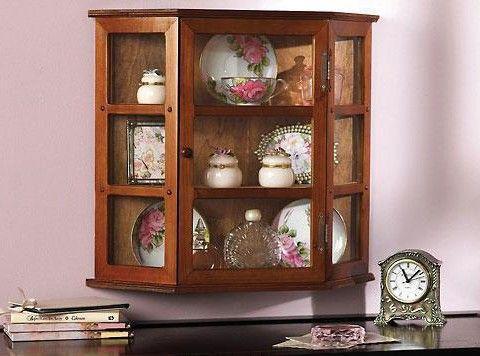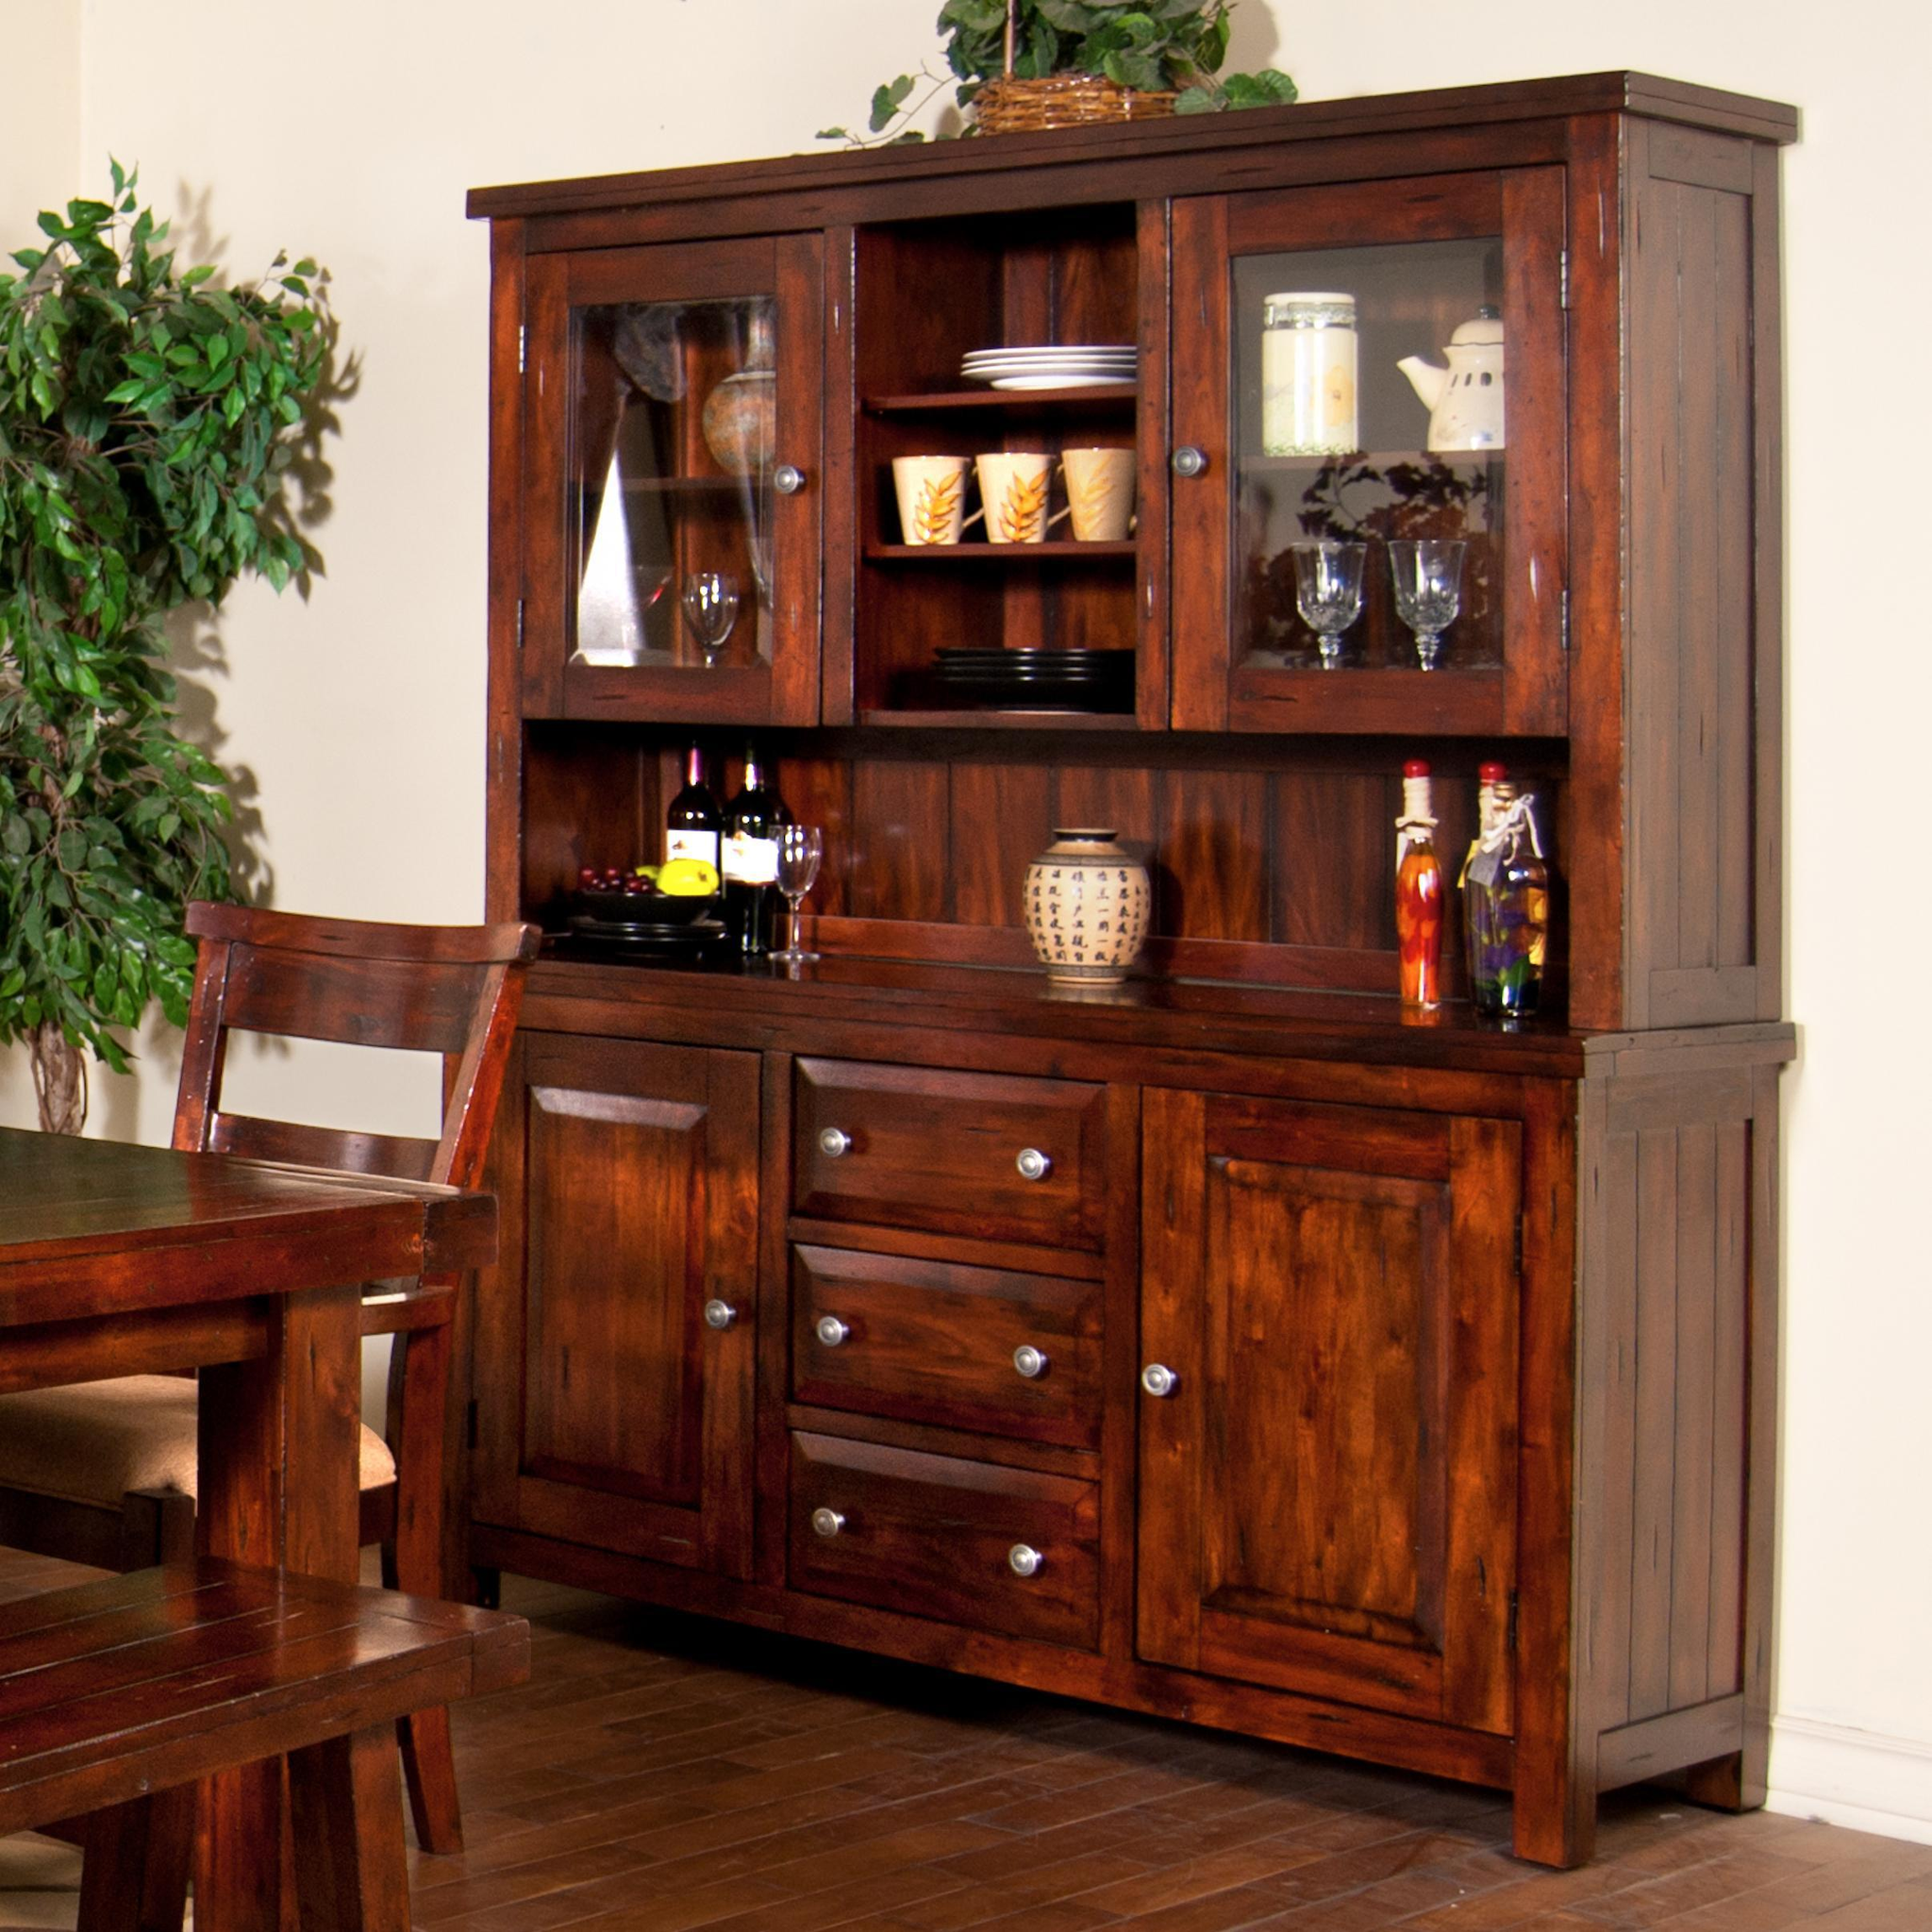The first image is the image on the left, the second image is the image on the right. Examine the images to the left and right. Is the description "One image shows a bright white cabinet with a flat top." accurate? Answer yes or no. No. 